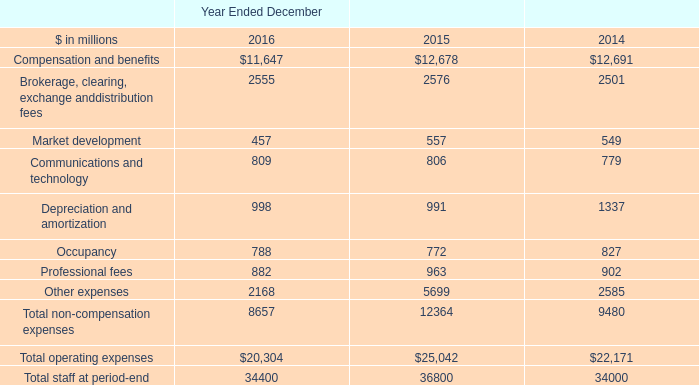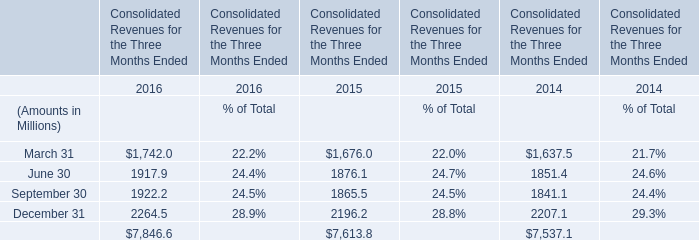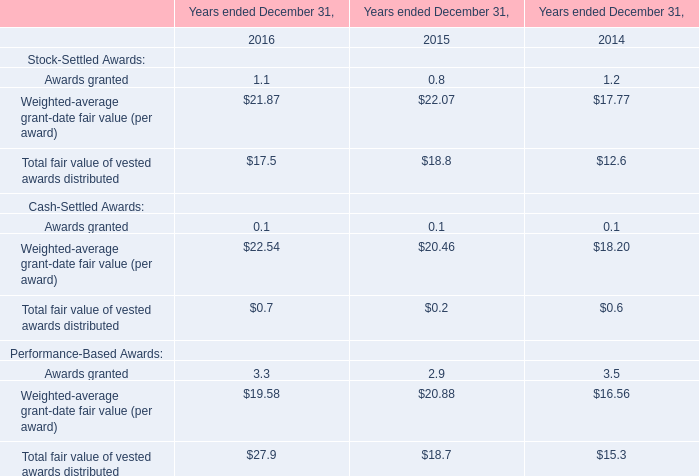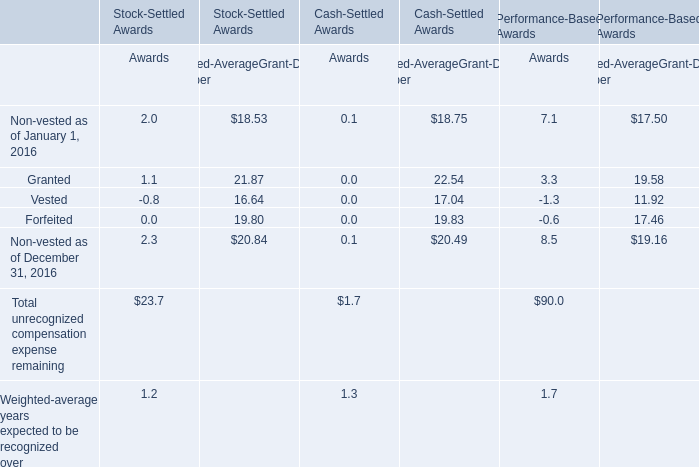What is the percentage of all Awards that are positive to the total amount, in 2016 for Stock-Settled Awards?? 
Computations: (((((2.0 + 1.1) + 2.3) + 23.7) + 1.2) / (((((2.0 + 1.1) + 2.3) + 23.7) + 1.2) - 0.8))
Answer: 1.02712. 